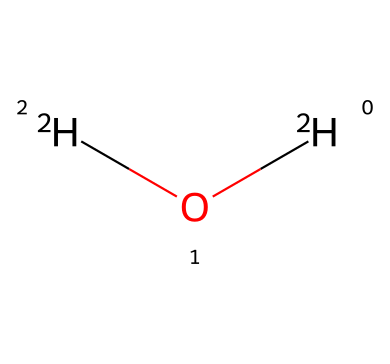What isotopes are present in the water molecule? The chemical structure contains deuterium ([2H]O[2H]), oxygen-18 ([18O]), and oxygen-17 ([17O]). These represent the isotopes of hydrogen and oxygen in water.
Answer: deuterium, oxygen-18, oxygen-17 How many hydrogen atoms are in the molecule? Analyzing the SMILES representation, [2H]O[2H] indicates there are two hydrogen atoms present in the water molecule.
Answer: 2 What element is represented by the letter "O" in the structure? The letter "O" represents oxygen, which is identified in the chemical by its presence in the water structure alongside the isotopes.
Answer: oxygen Which isotope has the highest atomic mass in this molecule? Among the isotopes present, oxygen-18 ([18O]) has the highest atomic mass compared to deuterium and oxygen-17.
Answer: oxygen-18 What does the presence of deuterium in this structure indicate? The presence of deuterium ([2H]) indicates that this water molecule is an isotopologue known as heavy water, which can affect its properties in climate studies.
Answer: heavy water How does the isotopic composition of water impact climate research? The isotopic composition (ratio of deuterium to hydrogen and oxygen isotopes) can be used to analyze past climate conditions and water cycles through proxies.
Answer: climate proxies 